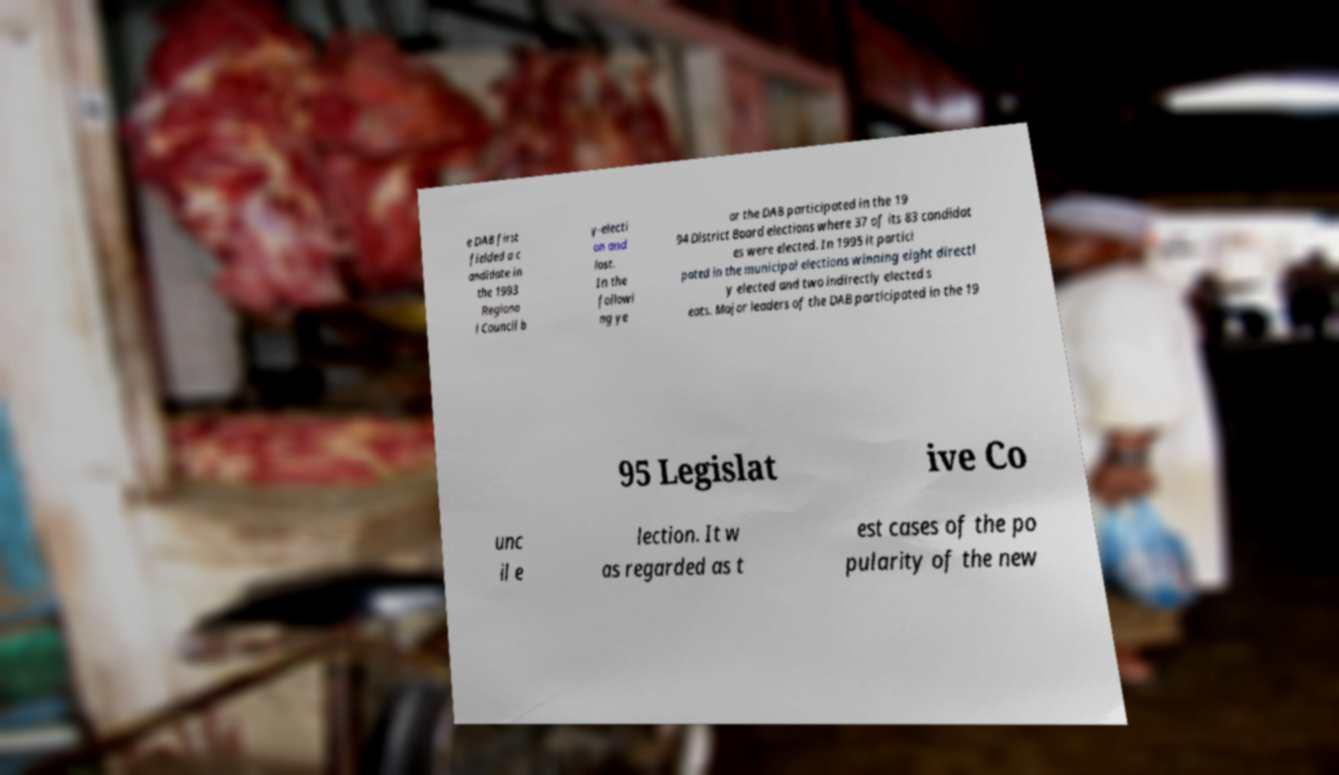Please read and relay the text visible in this image. What does it say? e DAB first fielded a c andidate in the 1993 Regiona l Council b y-electi on and lost. In the followi ng ye ar the DAB participated in the 19 94 District Board elections where 37 of its 83 candidat es were elected. In 1995 it partici pated in the municipal elections winning eight directl y elected and two indirectly elected s eats. Major leaders of the DAB participated in the 19 95 Legislat ive Co unc il e lection. It w as regarded as t est cases of the po pularity of the new 